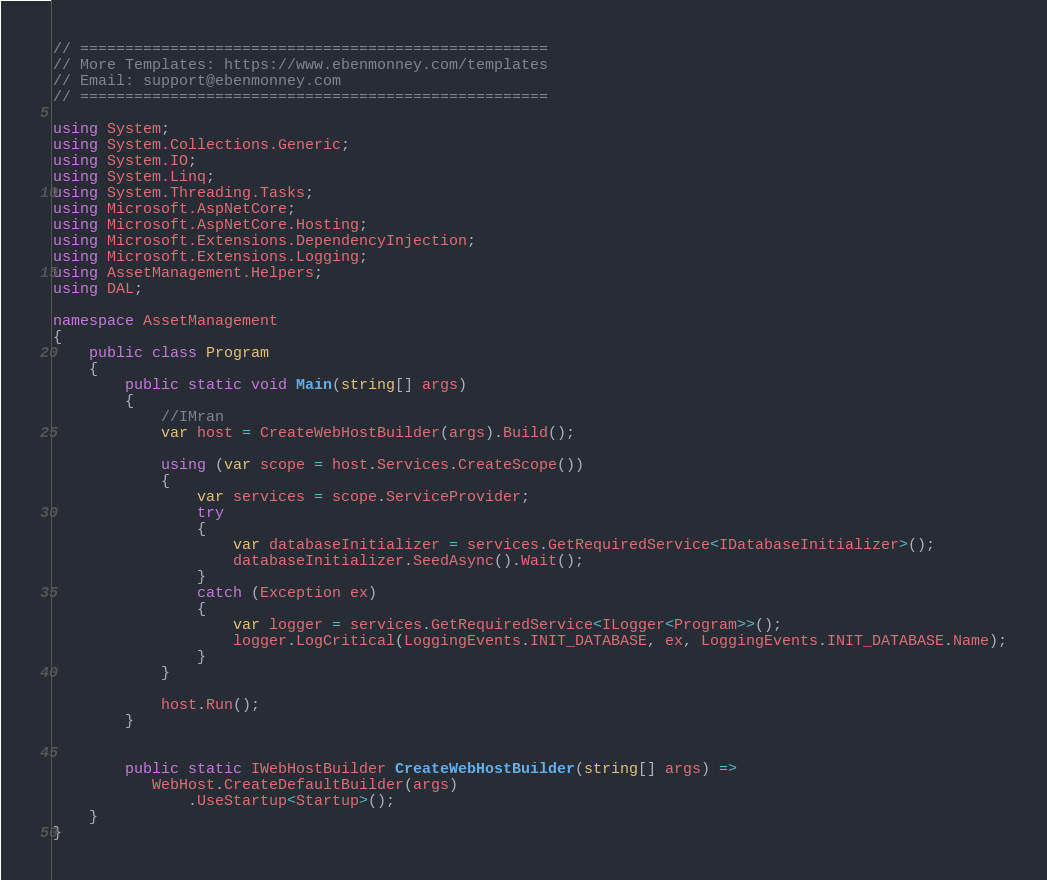Convert code to text. <code><loc_0><loc_0><loc_500><loc_500><_C#_>// ====================================================
// More Templates: https://www.ebenmonney.com/templates
// Email: support@ebenmonney.com
// ====================================================

using System;
using System.Collections.Generic;
using System.IO;
using System.Linq;
using System.Threading.Tasks;
using Microsoft.AspNetCore;
using Microsoft.AspNetCore.Hosting;
using Microsoft.Extensions.DependencyInjection;
using Microsoft.Extensions.Logging;
using AssetManagement.Helpers;
using DAL;

namespace AssetManagement
{
    public class Program
    {
        public static void Main(string[] args)
        {
            //IMran
            var host = CreateWebHostBuilder(args).Build();

            using (var scope = host.Services.CreateScope())
            {
                var services = scope.ServiceProvider;
                try
                {
                    var databaseInitializer = services.GetRequiredService<IDatabaseInitializer>();
                    databaseInitializer.SeedAsync().Wait();
                }
                catch (Exception ex)
                {
                    var logger = services.GetRequiredService<ILogger<Program>>();
                    logger.LogCritical(LoggingEvents.INIT_DATABASE, ex, LoggingEvents.INIT_DATABASE.Name);
                }
            }

            host.Run();
        }


        public static IWebHostBuilder CreateWebHostBuilder(string[] args) =>
           WebHost.CreateDefaultBuilder(args)
               .UseStartup<Startup>();
    }
}
</code> 